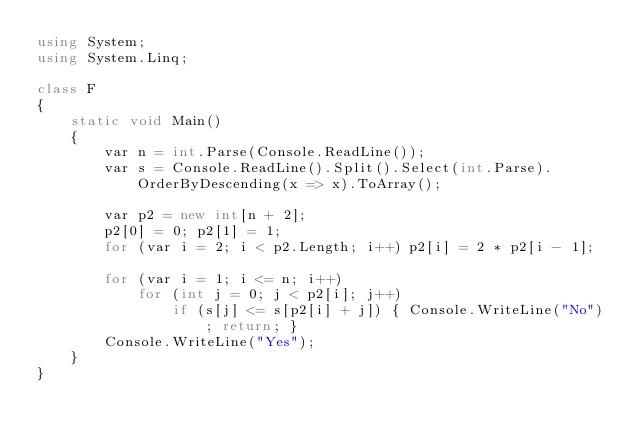<code> <loc_0><loc_0><loc_500><loc_500><_C#_>using System;
using System.Linq;

class F
{
	static void Main()
	{
		var n = int.Parse(Console.ReadLine());
		var s = Console.ReadLine().Split().Select(int.Parse).OrderByDescending(x => x).ToArray();

		var p2 = new int[n + 2];
		p2[0] = 0; p2[1] = 1;
		for (var i = 2; i < p2.Length; i++) p2[i] = 2 * p2[i - 1];

		for (var i = 1; i <= n; i++)
			for (int j = 0; j < p2[i]; j++)
				if (s[j] <= s[p2[i] + j]) { Console.WriteLine("No"); return; }
		Console.WriteLine("Yes");
	}
}
</code> 